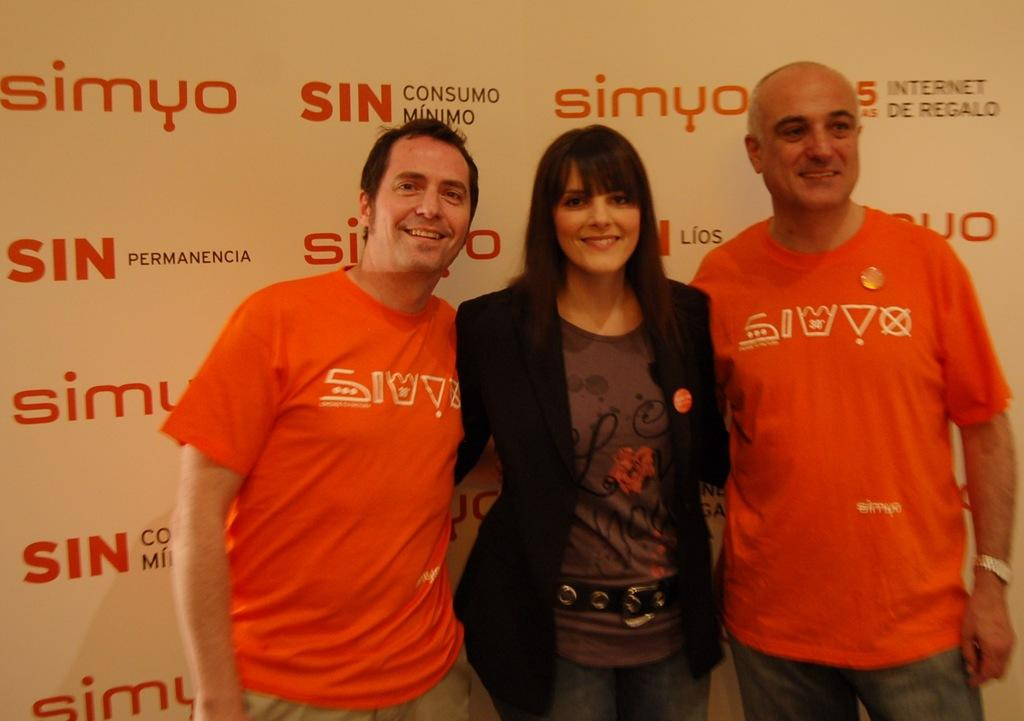How many people are in the image? There are three persons in the image. What are the persons wearing? The persons are wearing clothes. What can be seen behind the persons in the image? The persons are standing in front of a banner. What type of riddle is written on the banner in the image? There is no riddle visible on the banner in the image. Can you see a kettle in the image? There is no kettle present in the image. 